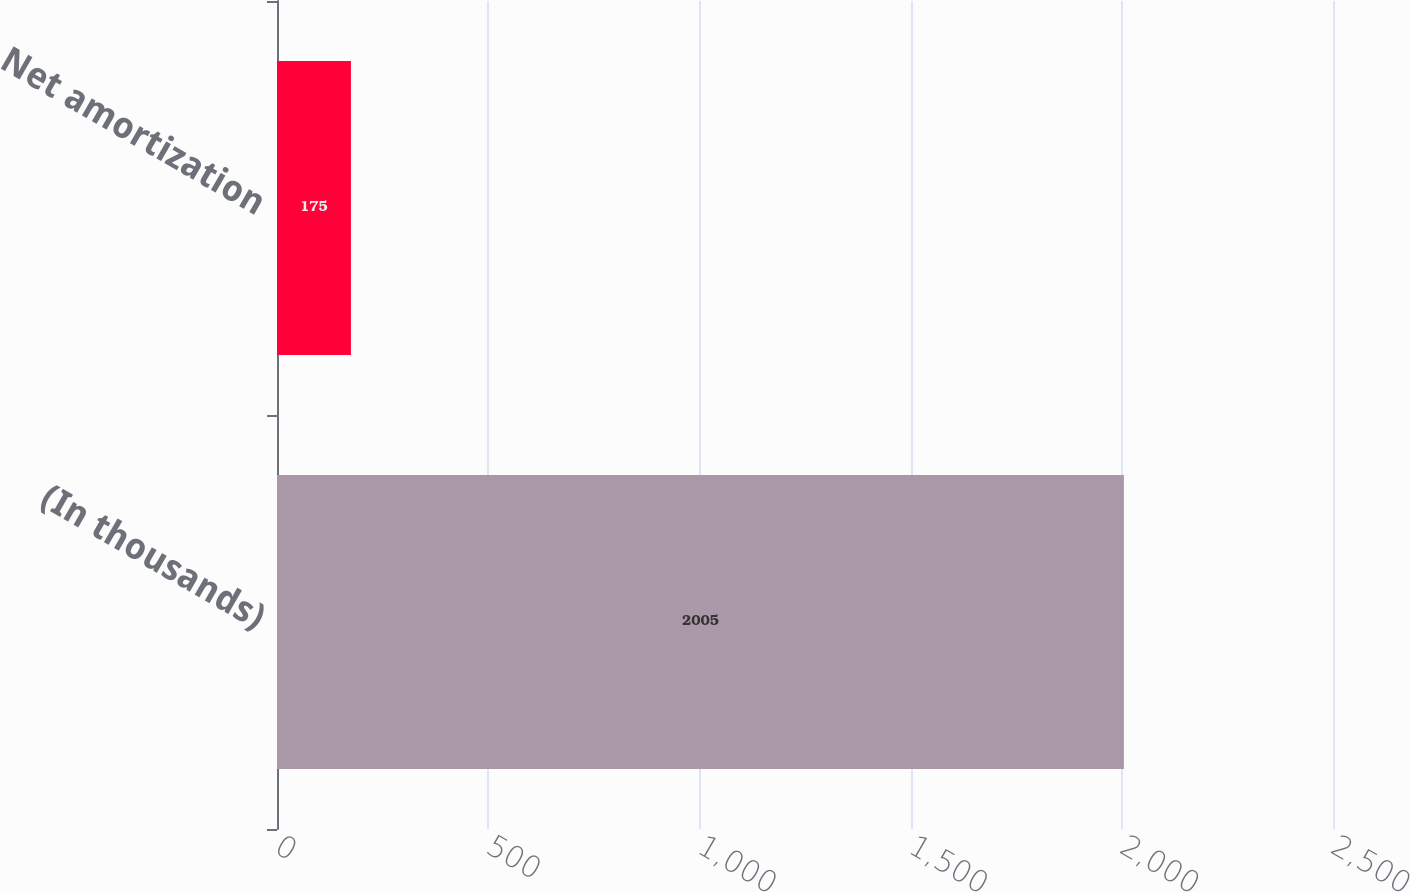Convert chart to OTSL. <chart><loc_0><loc_0><loc_500><loc_500><bar_chart><fcel>(In thousands)<fcel>Net amortization<nl><fcel>2005<fcel>175<nl></chart> 